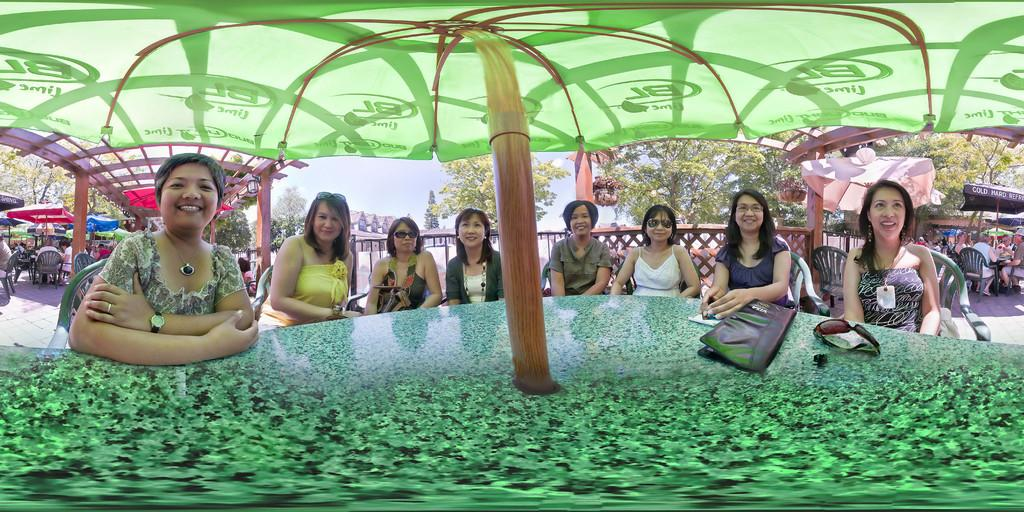What are the people in the image doing? The people in the image are sitting on chairs. What is located in front of the people sitting on chairs? There is a table in front of the people sitting on chairs. What is placed on the table? Objects are placed on the table. What can be seen behind the table? There are people and chairs visible behind the table. What else is visible behind the table? There are tables visible behind the table. What is visible in the background of the image? Trees are present in the background of the image. What type of air can be seen in the image? There is no air visible in the image; it is a still image. Is there any quicksand present in the image? There is no quicksand present in the image. 